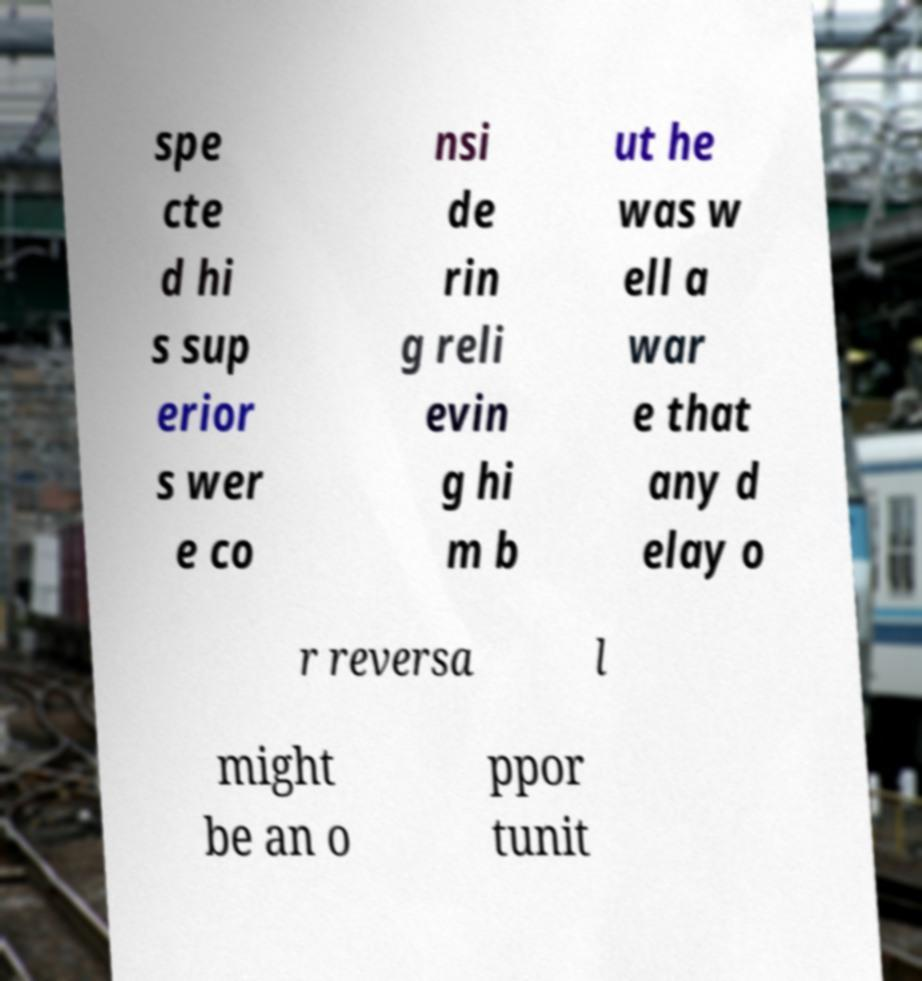Could you assist in decoding the text presented in this image and type it out clearly? spe cte d hi s sup erior s wer e co nsi de rin g reli evin g hi m b ut he was w ell a war e that any d elay o r reversa l might be an o ppor tunit 